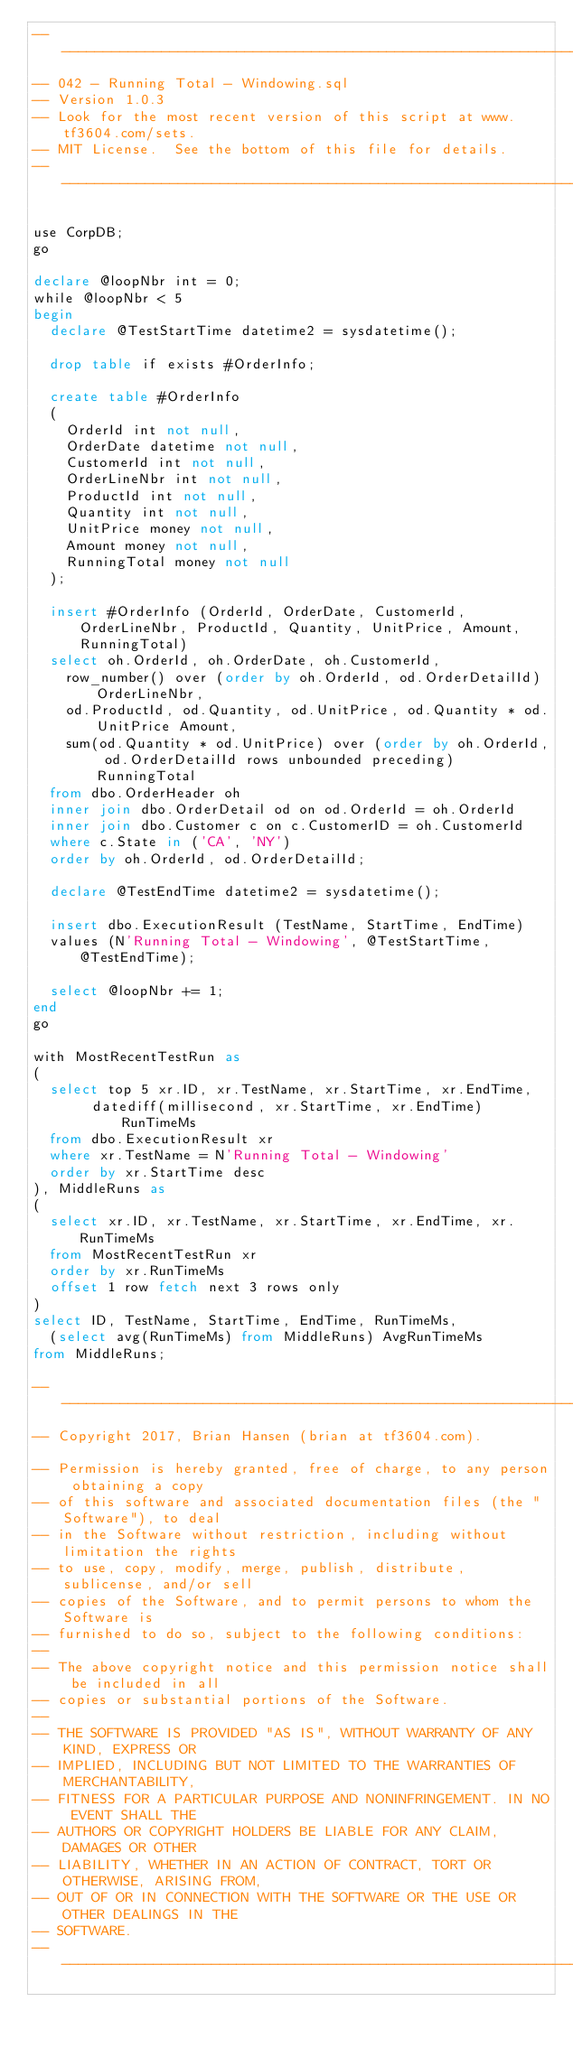Convert code to text. <code><loc_0><loc_0><loc_500><loc_500><_SQL_>-----------------------------------------------------------------------------------------------------------------------
-- 042 - Running Total - Windowing.sql
-- Version 1.0.3
-- Look for the most recent version of this script at www.tf3604.com/sets.
-- MIT License.  See the bottom of this file for details.
-----------------------------------------------------------------------------------------------------------------------

use CorpDB;
go

declare @loopNbr int = 0;
while @loopNbr < 5
begin
	declare @TestStartTime datetime2 = sysdatetime();

	drop table if exists #OrderInfo;

	create table #OrderInfo
	(
		OrderId int not null,
		OrderDate datetime not null,
		CustomerId int not null,
		OrderLineNbr int not null,
		ProductId int not null,
		Quantity int not null,
		UnitPrice money not null,
		Amount money not null,
		RunningTotal money not null
	);

	insert #OrderInfo (OrderId, OrderDate, CustomerId, OrderLineNbr, ProductId, Quantity, UnitPrice, Amount, RunningTotal)
	select oh.OrderId, oh.OrderDate, oh.CustomerId,
		row_number() over (order by oh.OrderId, od.OrderDetailId) OrderLineNbr,
		od.ProductId, od.Quantity, od.UnitPrice, od.Quantity * od.UnitPrice Amount,
		sum(od.Quantity * od.UnitPrice) over (order by oh.OrderId, od.OrderDetailId rows unbounded preceding) RunningTotal
	from dbo.OrderHeader oh
	inner join dbo.OrderDetail od on od.OrderId = oh.OrderId
	inner join dbo.Customer c on c.CustomerID = oh.CustomerId
	where c.State in ('CA', 'NY')
	order by oh.OrderId, od.OrderDetailId;

	declare @TestEndTime datetime2 = sysdatetime();

	insert dbo.ExecutionResult (TestName, StartTime, EndTime)
	values (N'Running Total - Windowing', @TestStartTime, @TestEndTime);

	select @loopNbr += 1;
end
go

with MostRecentTestRun as
(
	select top 5 xr.ID, xr.TestName, xr.StartTime, xr.EndTime,
		   datediff(millisecond, xr.StartTime, xr.EndTime) RunTimeMs
	from dbo.ExecutionResult xr
	where xr.TestName = N'Running Total - Windowing'
	order by xr.StartTime desc
), MiddleRuns as
(
	select xr.ID, xr.TestName, xr.StartTime, xr.EndTime, xr.RunTimeMs
	from MostRecentTestRun xr
	order by xr.RunTimeMs
	offset 1 row fetch next 3 rows only
)
select ID, TestName, StartTime, EndTime, RunTimeMs,
	(select avg(RunTimeMs) from MiddleRuns) AvgRunTimeMs
from MiddleRuns;

-----------------------------------------------------------------------------------------------------------------------
-- Copyright 2017, Brian Hansen (brian at tf3604.com).

-- Permission is hereby granted, free of charge, to any person obtaining a copy
-- of this software and associated documentation files (the "Software"), to deal
-- in the Software without restriction, including without limitation the rights
-- to use, copy, modify, merge, publish, distribute, sublicense, and/or sell
-- copies of the Software, and to permit persons to whom the Software is
-- furnished to do so, subject to the following conditions:
-- 
-- The above copyright notice and this permission notice shall be included in all
-- copies or substantial portions of the Software.
-- 
-- THE SOFTWARE IS PROVIDED "AS IS", WITHOUT WARRANTY OF ANY KIND, EXPRESS OR
-- IMPLIED, INCLUDING BUT NOT LIMITED TO THE WARRANTIES OF MERCHANTABILITY,
-- FITNESS FOR A PARTICULAR PURPOSE AND NONINFRINGEMENT. IN NO EVENT SHALL THE
-- AUTHORS OR COPYRIGHT HOLDERS BE LIABLE FOR ANY CLAIM, DAMAGES OR OTHER
-- LIABILITY, WHETHER IN AN ACTION OF CONTRACT, TORT OR OTHERWISE, ARISING FROM,
-- OUT OF OR IN CONNECTION WITH THE SOFTWARE OR THE USE OR OTHER DEALINGS IN THE
-- SOFTWARE.
-----------------------------------------------------------------------------------------------------------------------

</code> 